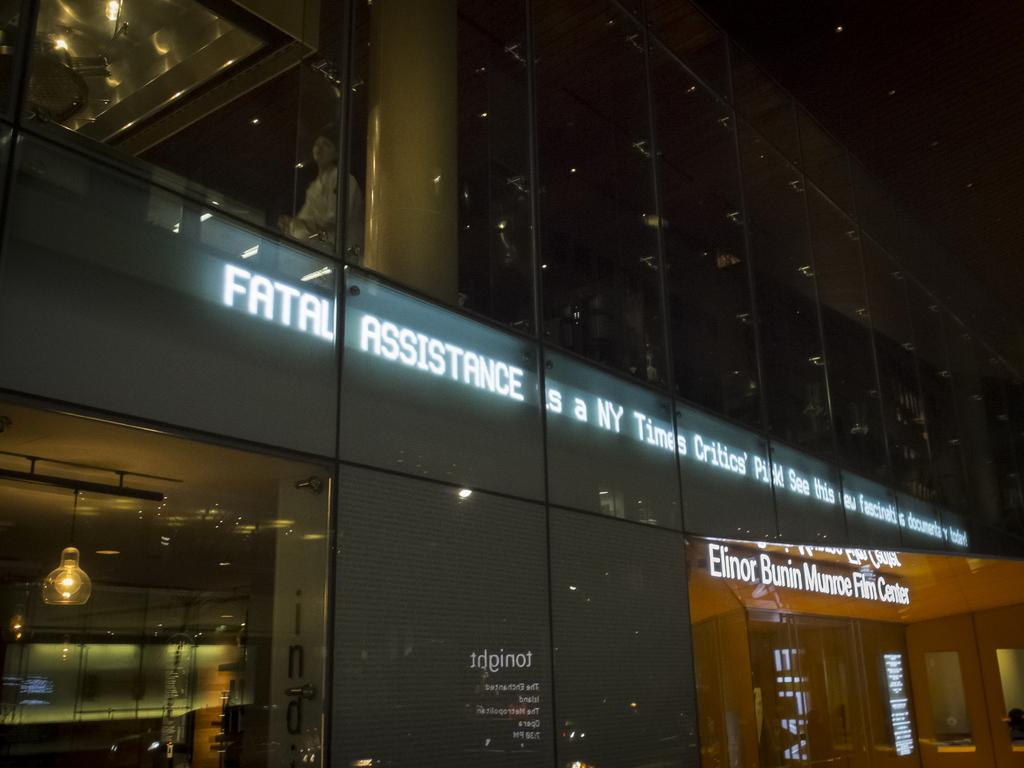What type of building is shown in the image? There is a glass building in the image. What can be seen on the building? There is text visible on the building. Are there any people in the image? Yes, there is a person in the image. What is the name of the person crying in the image? There is no person crying in the image; the person is not displaying any emotions. 